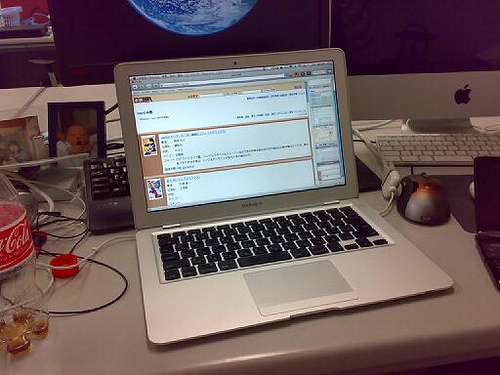<image>What animal is this? I don't know. There is no animal in the image. What animal is this? It is ambiguous what animal is this. It can be seen as either a human or a mouse. 